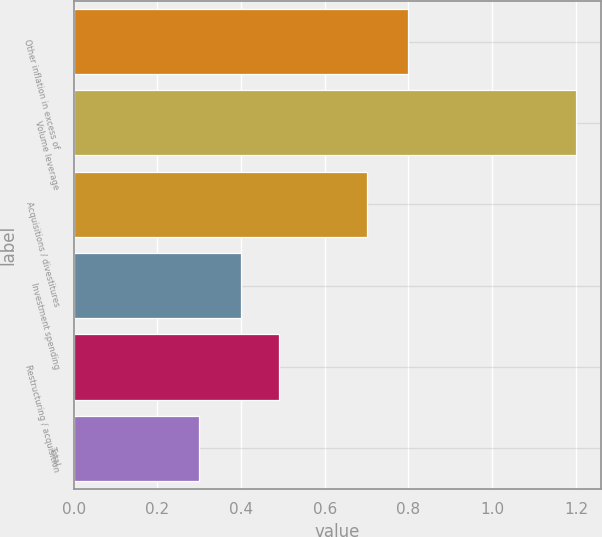<chart> <loc_0><loc_0><loc_500><loc_500><bar_chart><fcel>Other inflation in excess of<fcel>Volume leverage<fcel>Acquisitions / divestitures<fcel>Investment spending<fcel>Restructuring / acquisition<fcel>Total<nl><fcel>0.8<fcel>1.2<fcel>0.7<fcel>0.4<fcel>0.49<fcel>0.3<nl></chart> 